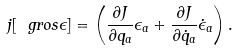<formula> <loc_0><loc_0><loc_500><loc_500>j [ { \ g r o s \epsilon } ] = \left ( \frac { \partial J } { \partial q _ { a } } \epsilon _ { a } + \frac { \partial J } { \partial \dot { q } _ { a } } \dot { \epsilon } _ { a } \right ) .</formula> 